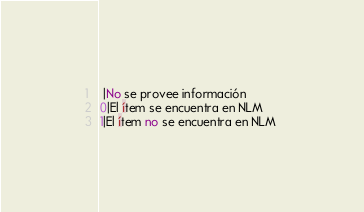<code> <loc_0><loc_0><loc_500><loc_500><_SQL_> |No se provee información 
0|El ítem se encuentra en NLM 
1|El ítem no se encuentra en NLM 
</code> 